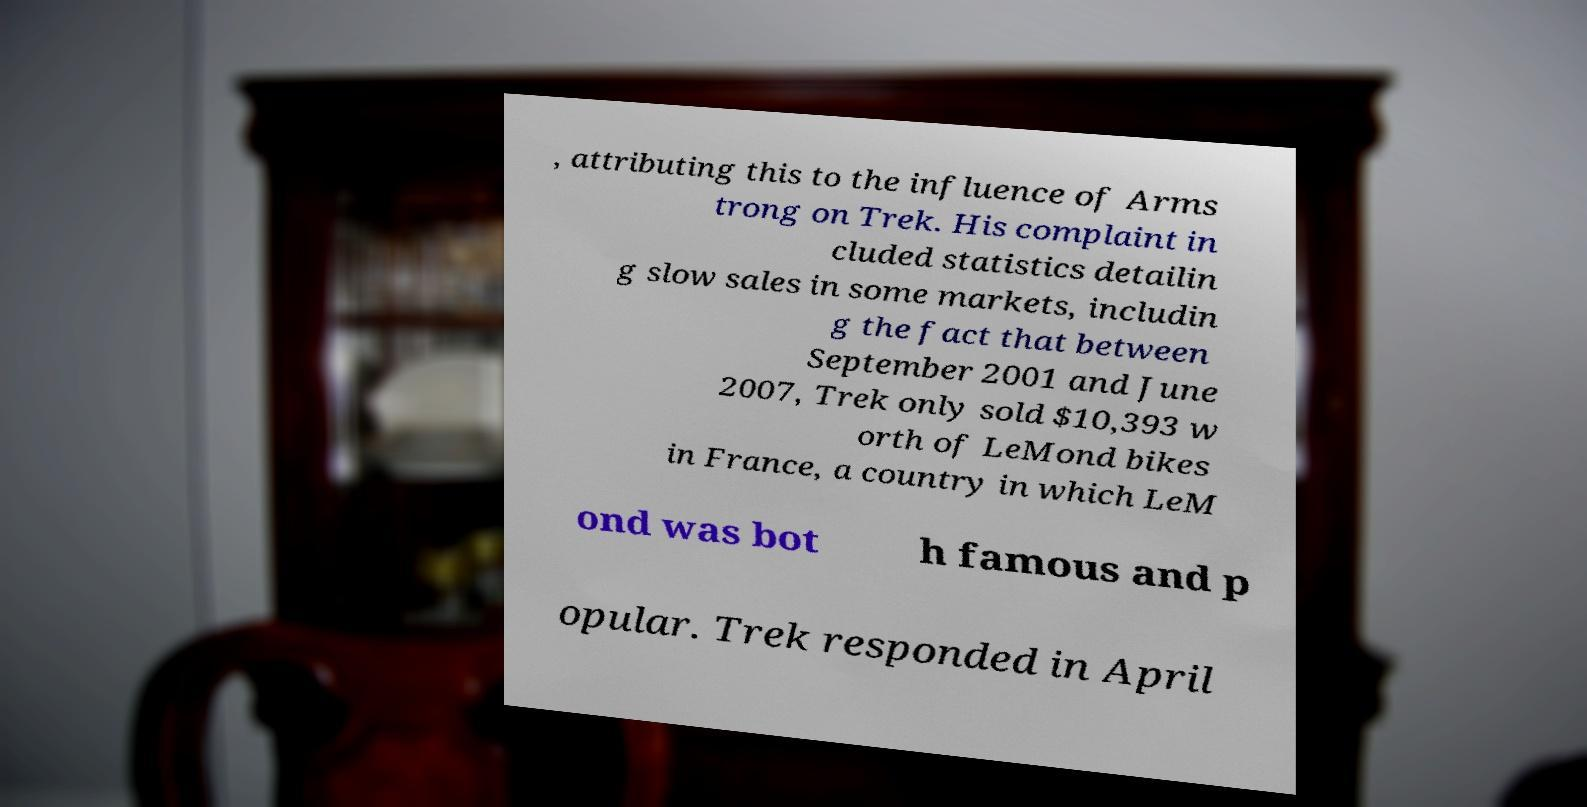Could you extract and type out the text from this image? , attributing this to the influence of Arms trong on Trek. His complaint in cluded statistics detailin g slow sales in some markets, includin g the fact that between September 2001 and June 2007, Trek only sold $10,393 w orth of LeMond bikes in France, a country in which LeM ond was bot h famous and p opular. Trek responded in April 